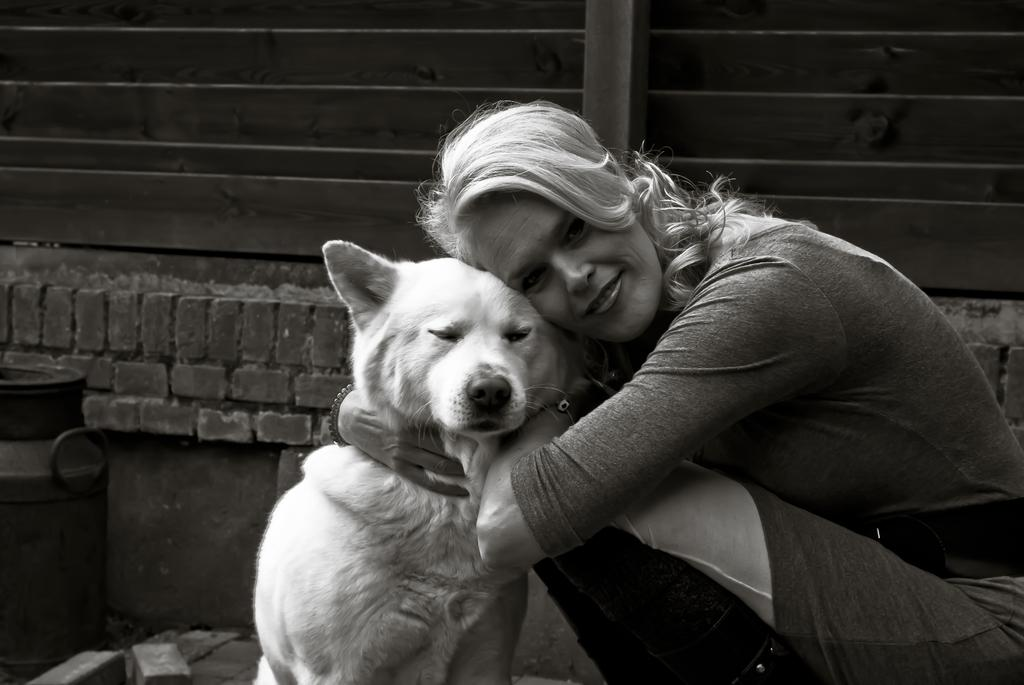Who is present in the image? There is a woman in the image. What is the woman doing in the image? The woman is sitting and holding a dog. How is the woman interacting with the dog? The woman is hugging the dog. What is the color scheme of the image? The image is in black and white color. What type of cactus can be seen in the image? There is no cactus present in the image. How does the twig contribute to the image's composition? There is no twig present in the image. 